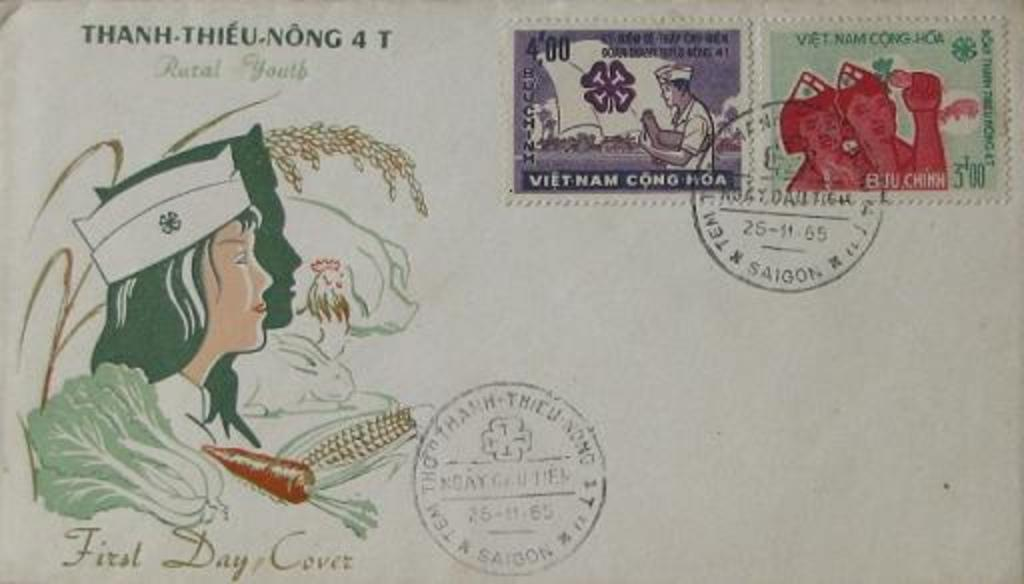<image>
Relay a brief, clear account of the picture shown. A postcard with the phrase first day cover in the left hand corner. 